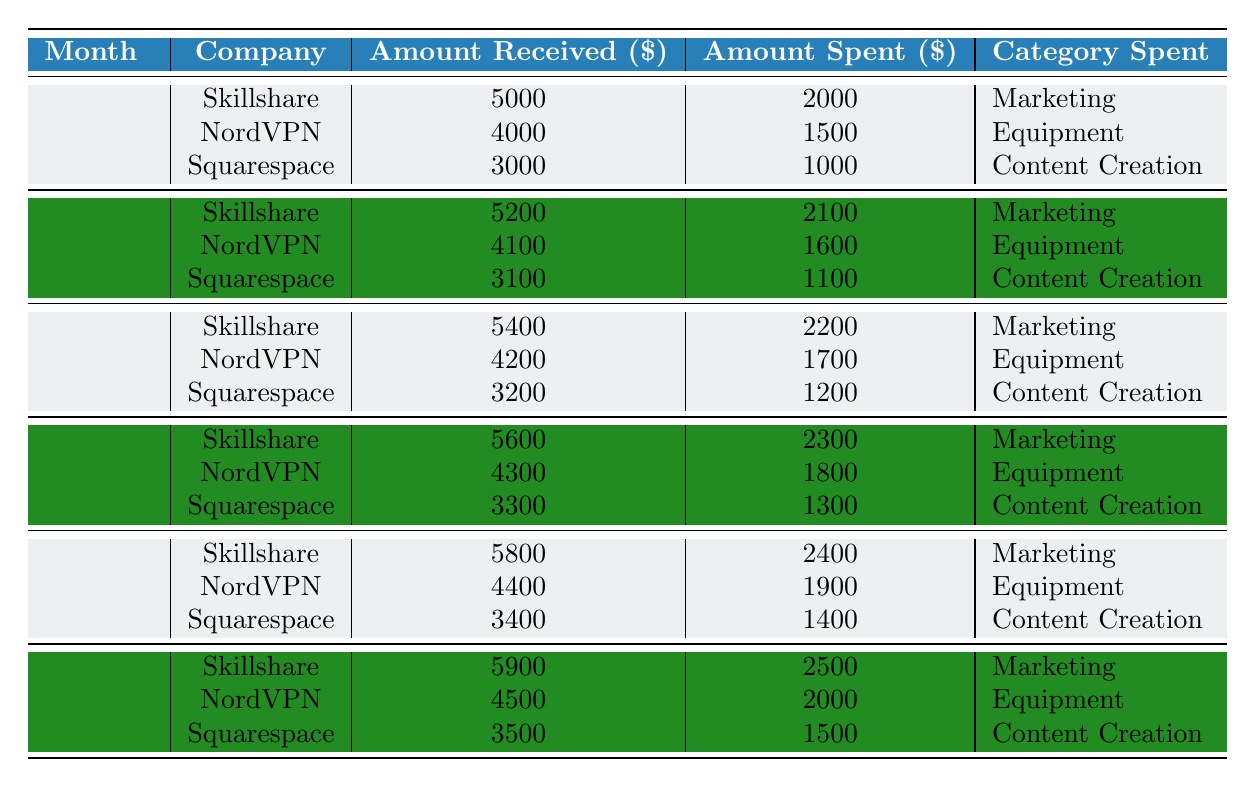What was the total amount received from sponsorships in April? In April, the amounts received from the sponsorships are: Skillshare: 5600, NordVPN: 4300, and Squarespace: 3300. Summing these gives 5600 + 4300 + 3300 = 13200.
Answer: 13200 Which company had the highest amount spent in June? In June, the amounts spent are: Skillshare: 2500, NordVPN: 2000, and Squarespace: 1500. Skillshare had the highest amount spent at 2500.
Answer: Skillshare What was the average amount received from all companies in May? The amounts received in May are: Skillshare: 5800, NordVPN: 4400, and Squarespace: 3400. To find the average, we sum these amounts (5800 + 4400 + 3400 = 13600) and divide by the number of companies (3), giving 13600 / 3 = 4533.33.
Answer: 4533.33 Did the amount spent on marketing increase every month? The amounts spent on marketing each month are: January: 2000, February: 2100, March: 2200, April: 2300, May: 2400, June: 2500. Observing these numbers, we see a consistent increase each month, confirming that it did increase every month.
Answer: Yes What is the total amount spent across all companies for the first three months? For the first three months: January: (2000 + 1500 + 1000 = 4500), February: (2100 + 1600 + 1100 = 4800), March: (2200 + 1700 + 1200 = 5100). Summing these totals gives 4500 + 4800 + 5100 = 14400.
Answer: 14400 